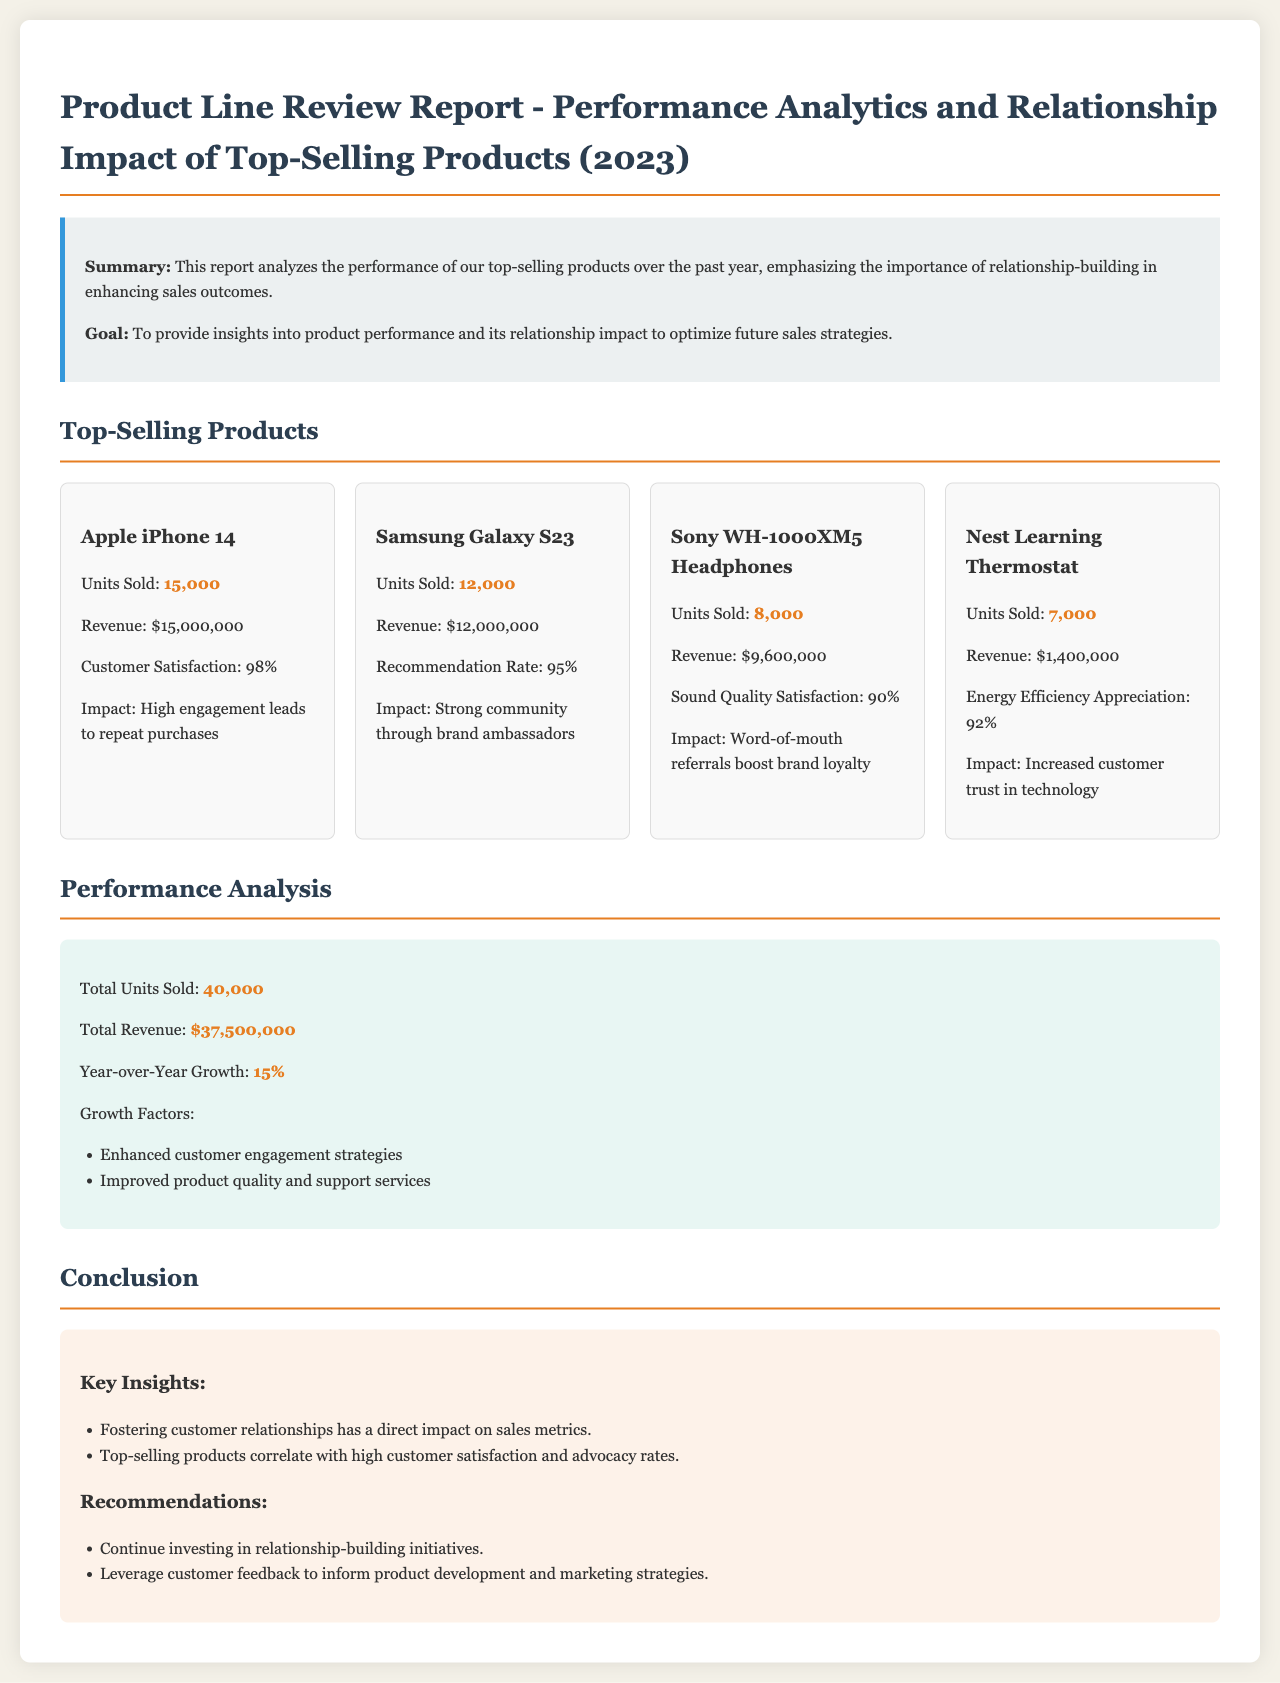What are the units sold for Apple iPhone 14? The document states 15,000 units were sold for Apple iPhone 14.
Answer: 15,000 What is the revenue generated by Samsung Galaxy S23? The document indicates that the revenue for Samsung Galaxy S23 is $12,000,000.
Answer: $12,000,000 What is the customer satisfaction rate for Sony WH-1000XM5 Headphones? The report mentions that customer satisfaction for these headphones is at 90%.
Answer: 90% What is the Year-over-Year Growth percentage? The document shows the Year-over-Year Growth as 15%.
Answer: 15% How many total units were sold across all products? The total units sold is calculated in the document as 40,000 units.
Answer: 40,000 What impact does customer engagement have on sales metrics according to the report? The report claims that fostering customer relationships has a direct impact on sales metrics.
Answer: Direct impact What can be inferred about the recommendation rate for Samsung Galaxy S23? The document states a recommendation rate of 95%, indicating strong customer advocacy.
Answer: 95% Which product has the highest revenue? The report highlights that Apple iPhone 14 generated the highest revenue of $15,000,000.
Answer: Apple iPhone 14 What are the growth factors mentioned in the report? The document lists enhanced customer engagement strategies and improved product quality and support services as growth factors.
Answer: Enhanced customer engagement strategies; Improved product quality and support services 